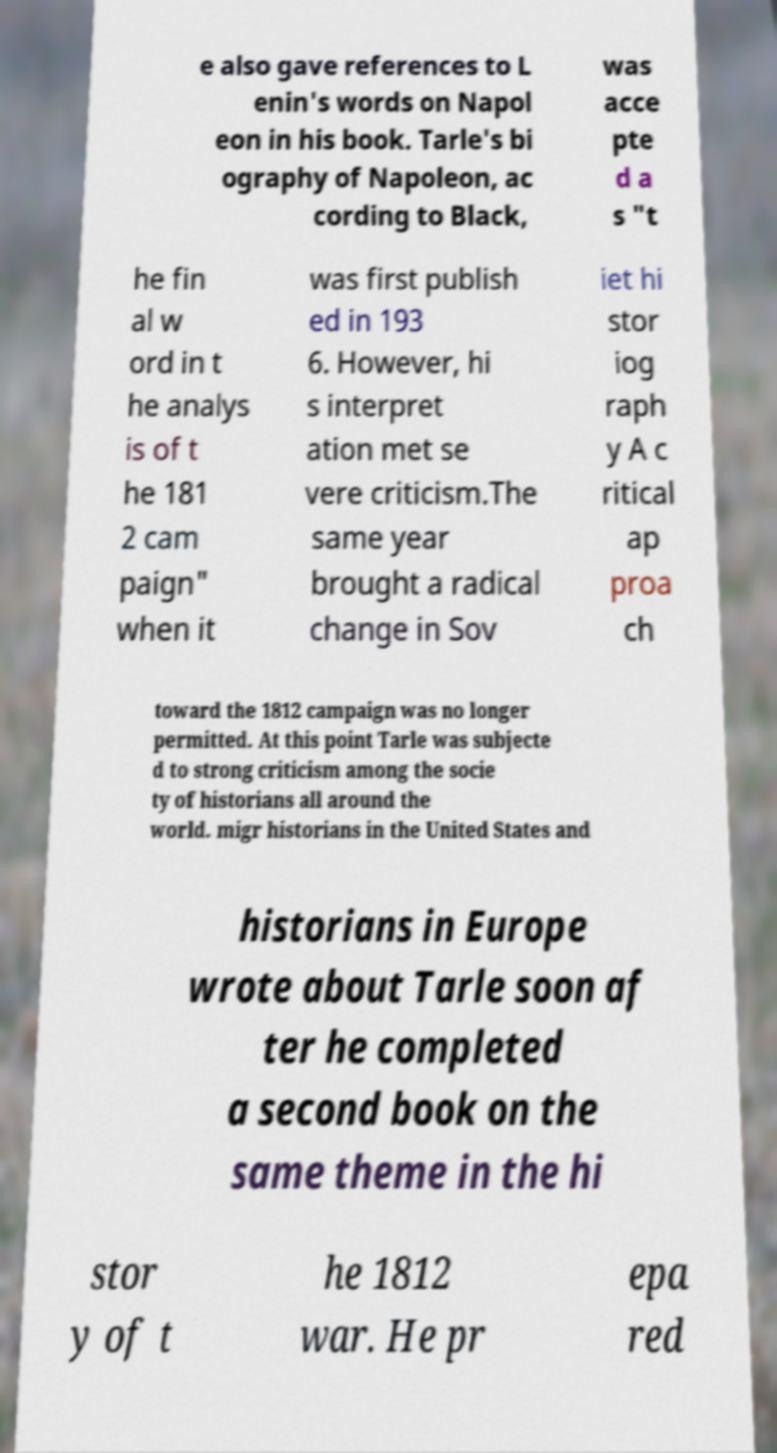Can you accurately transcribe the text from the provided image for me? e also gave references to L enin's words on Napol eon in his book. Tarle's bi ography of Napoleon, ac cording to Black, was acce pte d a s "t he fin al w ord in t he analys is of t he 181 2 cam paign" when it was first publish ed in 193 6. However, hi s interpret ation met se vere criticism.The same year brought a radical change in Sov iet hi stor iog raph y A c ritical ap proa ch toward the 1812 campaign was no longer permitted. At this point Tarle was subjecte d to strong criticism among the socie ty of historians all around the world. migr historians in the United States and historians in Europe wrote about Tarle soon af ter he completed a second book on the same theme in the hi stor y of t he 1812 war. He pr epa red 